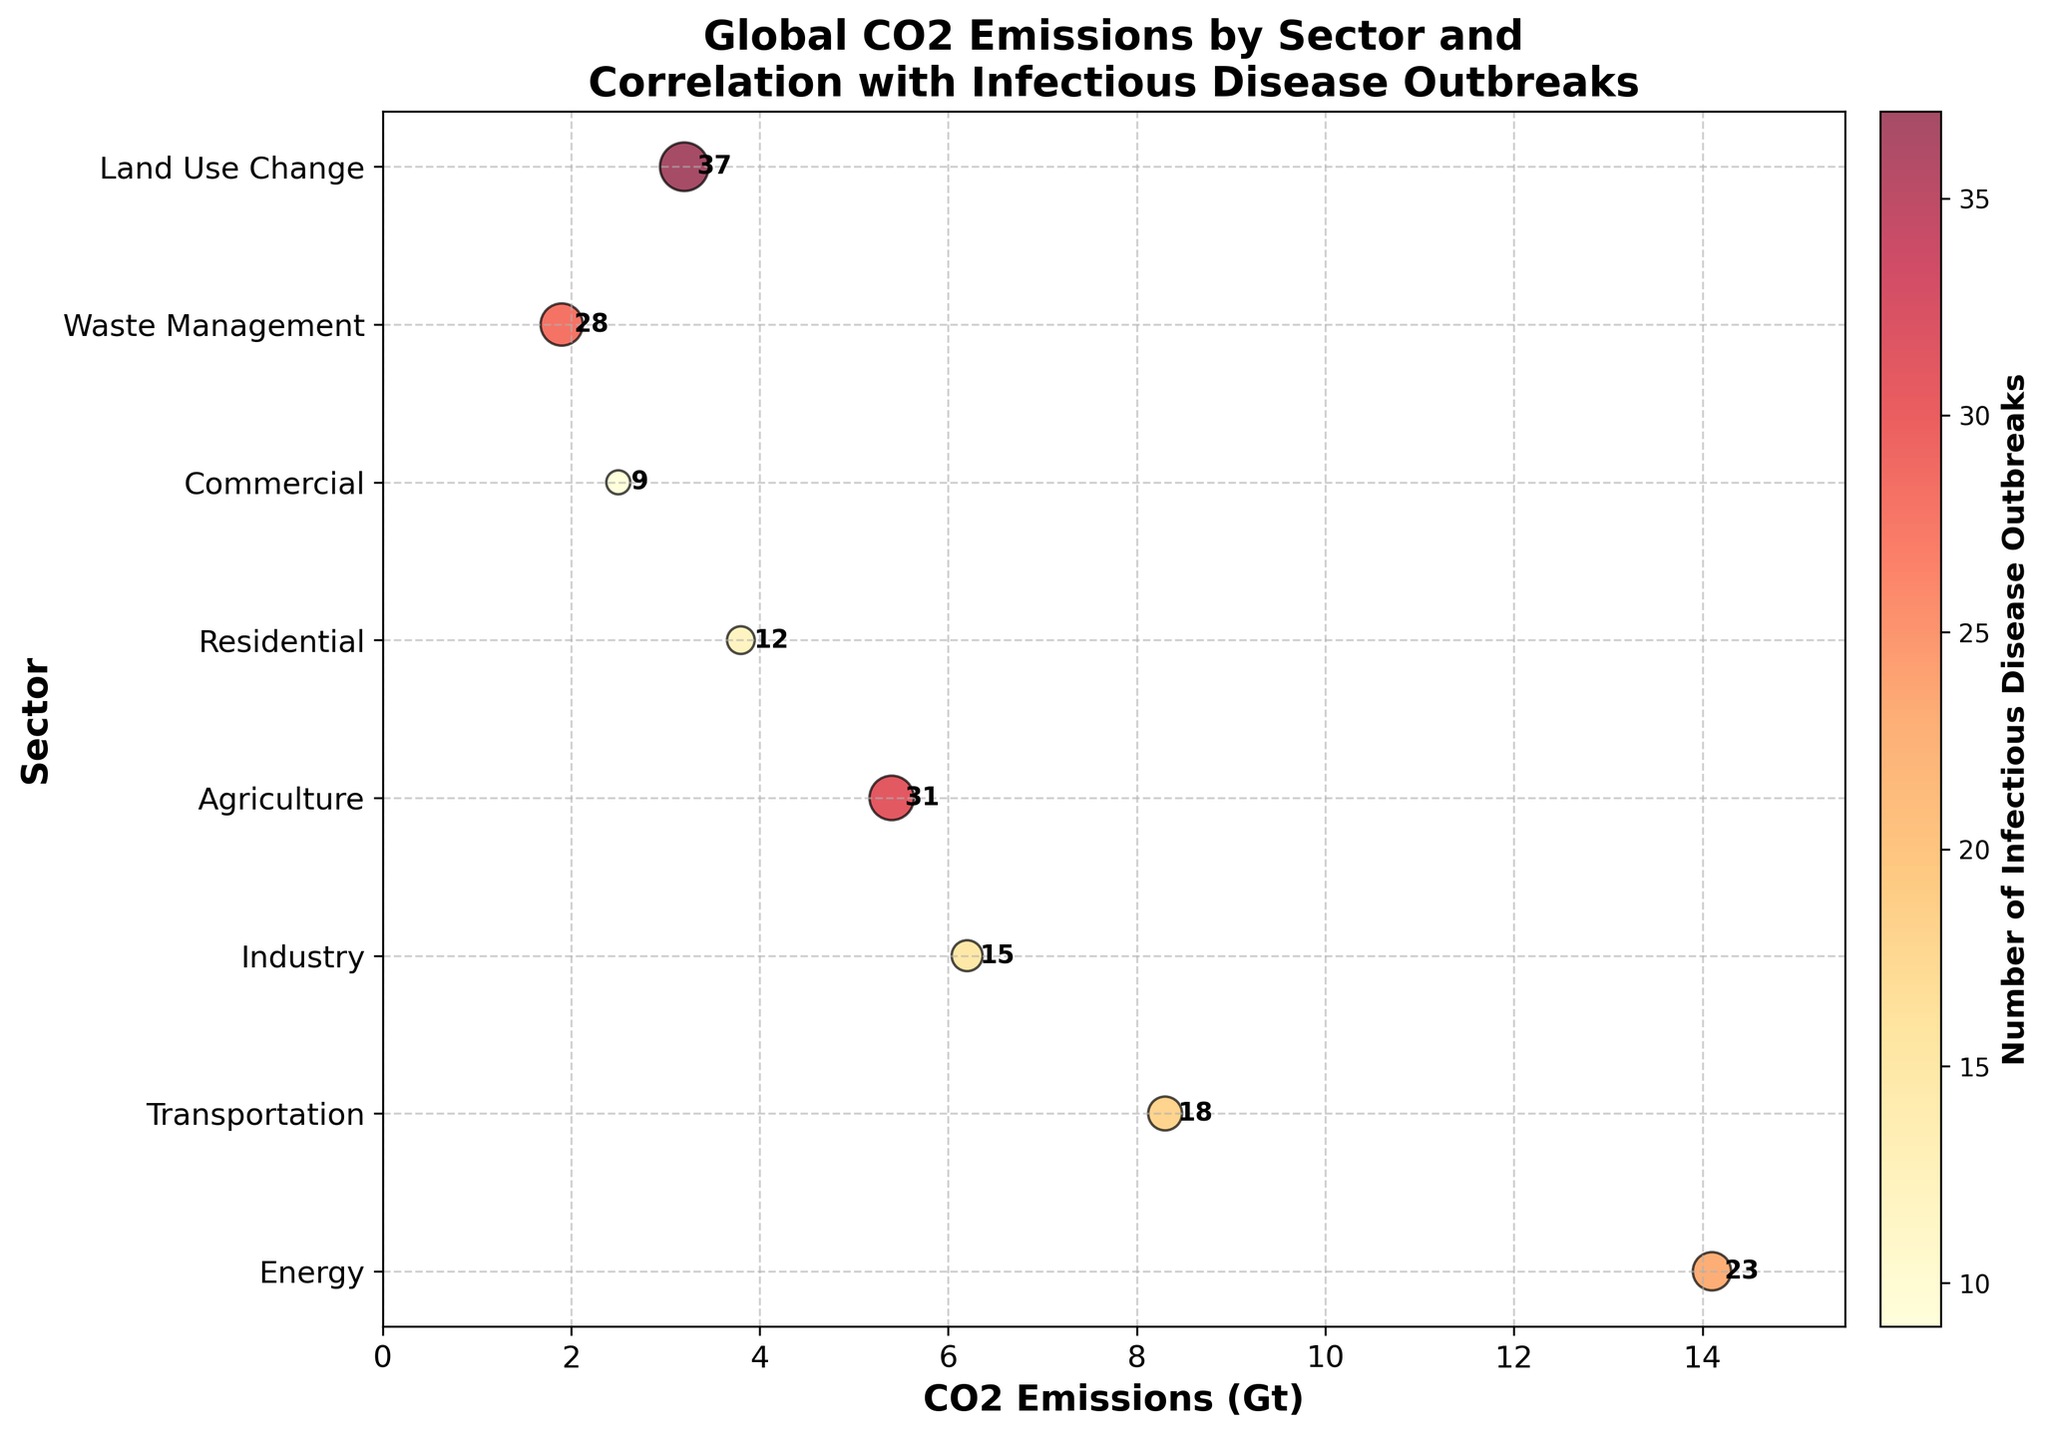Which sector has the highest CO2 emissions? The sector with the highest scatter point along the x-axis represents the highest CO2 emissions. The "Energy" sector has the highest position at 14.1 Gt.
Answer: Energy What is the number of infectious disease outbreaks in the Agriculture sector? Look for the "Agriculture" sector along the y-axis and refer to the text annotation next to its data point. The number is 31.
Answer: 31 Which sector has the lowest CO2 emissions? The sector with the lowest scatter point along the x-axis corresponds to the lowest CO2 emissions. The "Waste Management" sector has the lowest position at 1.9 Gt.
Answer: Waste Management How many sectors have CO2 emissions higher than 5 Gt? Count the sectors along the y-axis with scatter points positioned beyond the 5 Gt mark on the x-axis: Energy (14.1), Transportation (8.3), Industry (6.2), and Agriculture (5.4). There are 4.
Answer: 4 Which sector shows the highest number of infectious disease outbreaks and what is its CO2 emission? Find the sector with the highest text annotation next to its scatter point. "Land Use Change" has 37 outbreaks, and its CO2 emission is 3.2 Gt as observed on the x-axis.
Answer: Land Use Change, 3.2 Gt What is the median number of infectious disease outbreaks across all sectors? List the numbers of infectious disease outbreaks in ascending order: 9, 12, 15, 18, 23, 28, 31, 37. The median is the average of the 4th and 5th numbers: (18 + 23) / 2 = 20.5
Answer: 20.5 Which sectors have the same CO2 emissions and how can you tell? Check for sectors with scatter points aligned vertically at the same x-axis position. "Waste Management" and "Residential" do not align completely. The answer is none.
Answer: None Do sectors with higher CO2 emissions always correlate to more infectious disease outbreaks? Compare the scatter points: for instance, "Energy" (highest CO2 emissions) has fewer outbreaks (23) than "Land Use Change" (37), which has lower emissions. Thus, a higher correlation is not consistent.
Answer: No What's the average CO2 emission of all sectors combined? Sum the CO2 emissions: 14.1 + 8.3 + 6.2 + 5.4 + 3.8 + 2.5 + 1.9 + 3.2 = 45.4 Gt. Then, divide by the number of sectors (8): 45.4 / 8 = 5.675 Gt.
Answer: 5.675 Gt Which sector has the closest CO2 emission to 4 Gt? Identify the scatter point closest to the 4 Gt mark on the x-axis: "Residential" at 3.8 Gt is the closest.
Answer: Residential 